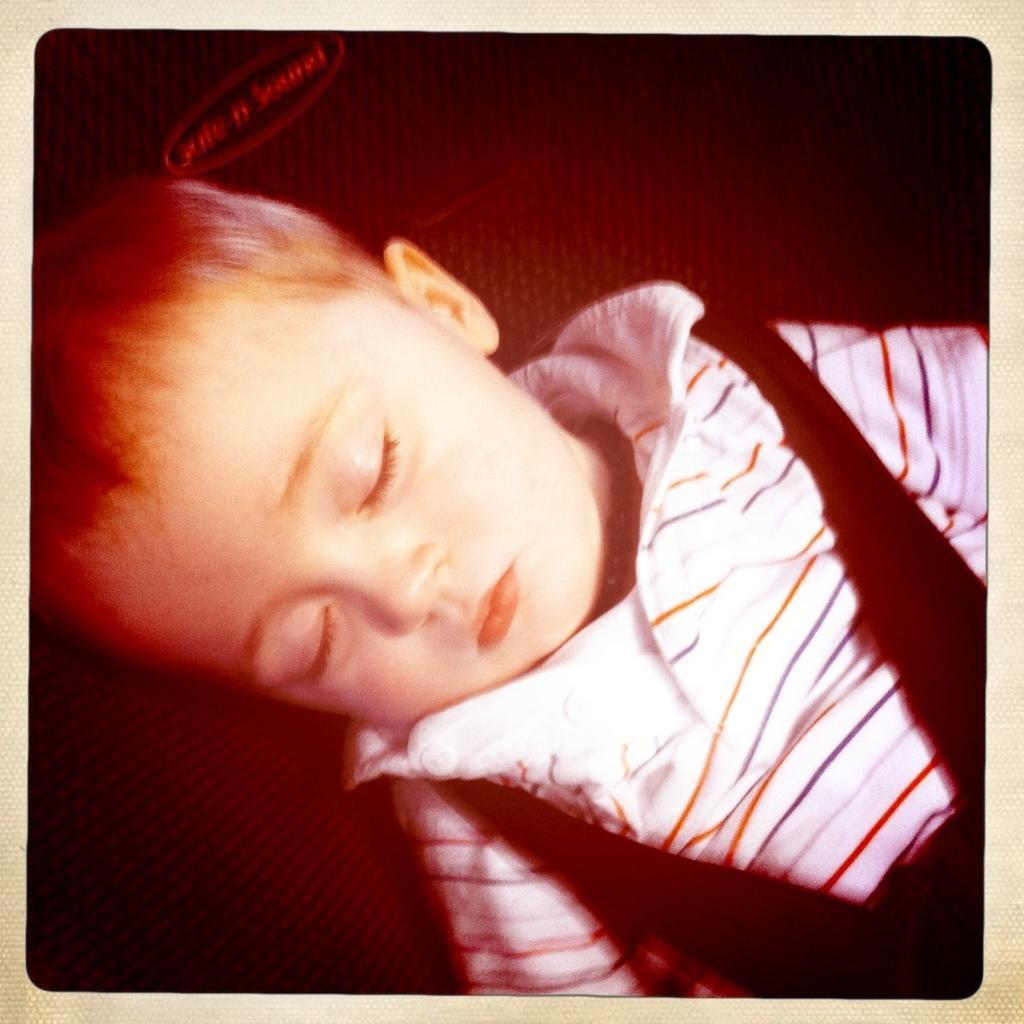Describe this image in one or two sentences. In this picture there is a kid wearing white and black color dress is sleeping. 